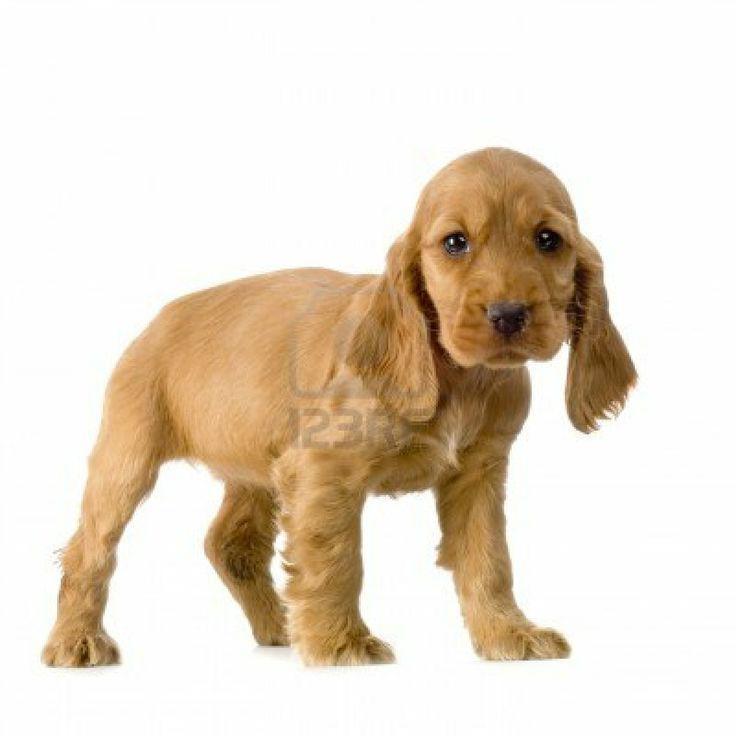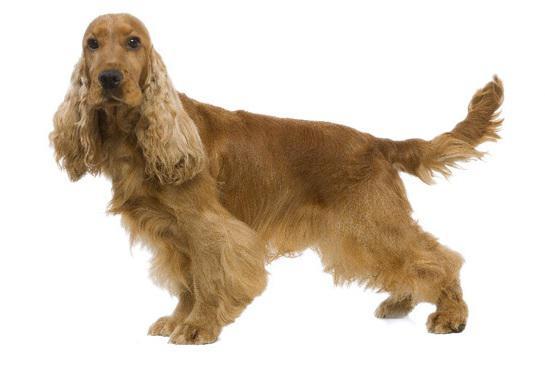The first image is the image on the left, the second image is the image on the right. Given the left and right images, does the statement "At least one of the images shows a Cocker Spaniel with their tongue out." hold true? Answer yes or no. No. The first image is the image on the left, the second image is the image on the right. Given the left and right images, does the statement "The combined images include one dog reclining with front paws extended and one dog with red-orange fur sitting upright." hold true? Answer yes or no. No. 